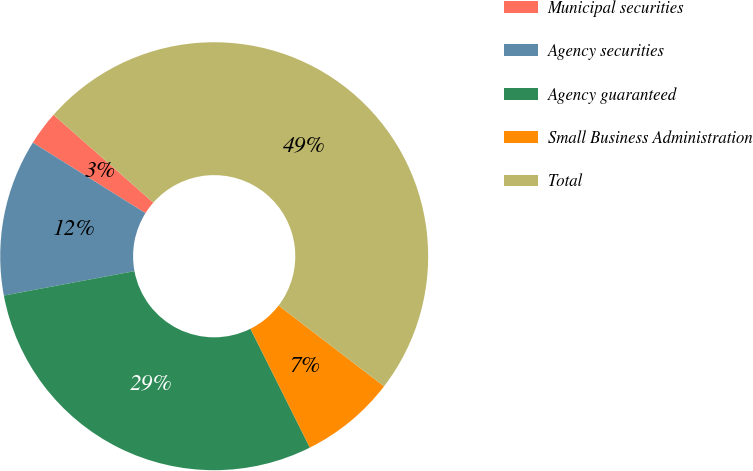Convert chart. <chart><loc_0><loc_0><loc_500><loc_500><pie_chart><fcel>Municipal securities<fcel>Agency securities<fcel>Agency guaranteed<fcel>Small Business Administration<fcel>Total<nl><fcel>2.58%<fcel>11.85%<fcel>29.44%<fcel>7.22%<fcel>48.92%<nl></chart> 